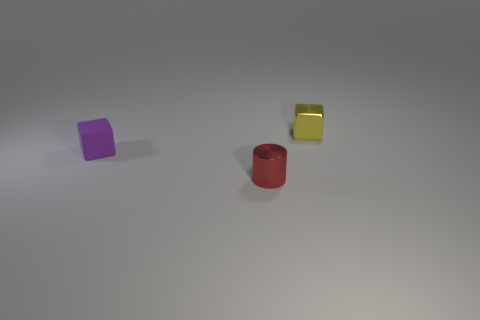How many small things are either purple metallic cubes or yellow things?
Give a very brief answer. 1. There is a red object; what number of tiny purple matte blocks are left of it?
Make the answer very short. 1. Is the number of objects that are behind the purple rubber thing greater than the number of big metal balls?
Keep it short and to the point. Yes. What shape is the tiny red thing that is made of the same material as the tiny yellow block?
Provide a short and direct response. Cylinder. The metal thing in front of the thing that is on the right side of the red shiny cylinder is what color?
Ensure brevity in your answer.  Red. Is the shape of the small purple rubber object the same as the yellow object?
Give a very brief answer. Yes. What material is the other small object that is the same shape as the small yellow thing?
Your answer should be very brief. Rubber. Is there a purple matte cube that is behind the tiny cube that is in front of the shiny thing behind the red object?
Offer a terse response. No. Do the tiny rubber object and the metal thing that is behind the tiny red thing have the same shape?
Provide a short and direct response. Yes. Are there any small green metallic balls?
Provide a short and direct response. No. 